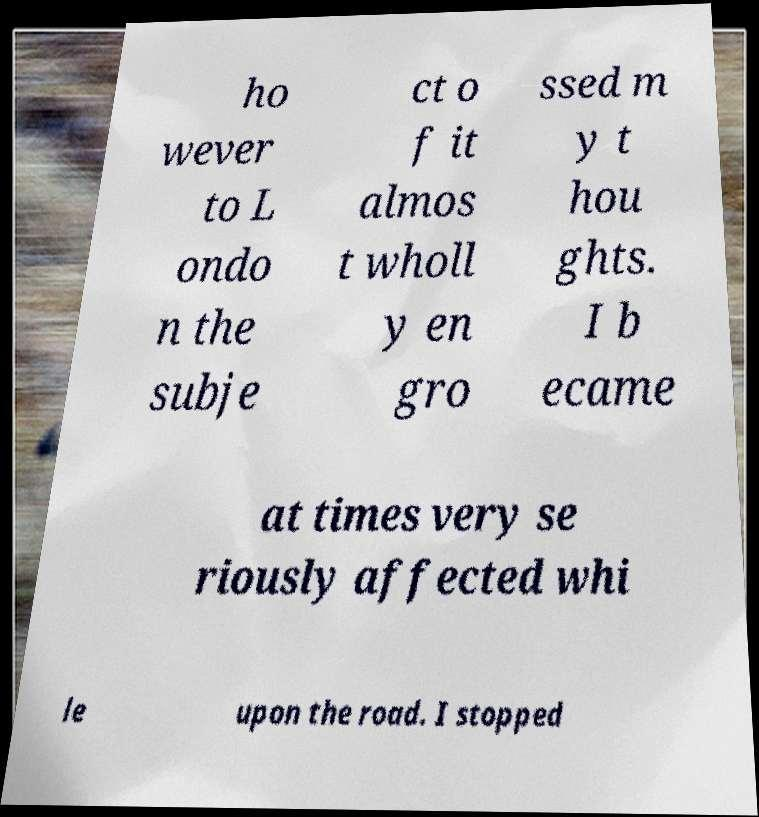Please read and relay the text visible in this image. What does it say? ho wever to L ondo n the subje ct o f it almos t wholl y en gro ssed m y t hou ghts. I b ecame at times very se riously affected whi le upon the road. I stopped 